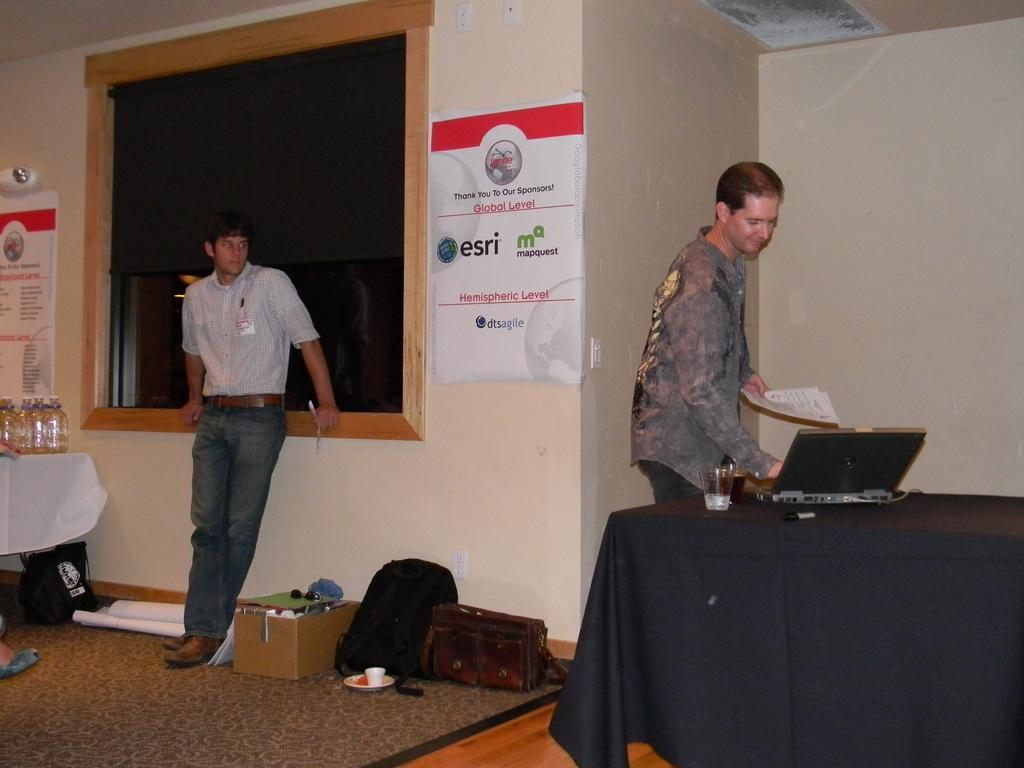What can be seen in the image involving people? There are people standing in the image. What object is present on the table in the image? There is a laptop on the table in the image. Are there any other items on the table besides the laptop? Yes, there is a wine glass on the table. What type of pancake is being served on the table in the image? There is no pancake present in the image; the table only has a laptop and a wine glass. Can you see any bushes in the image? There is no mention of bushes in the provided facts, and they are not visible in the image. 